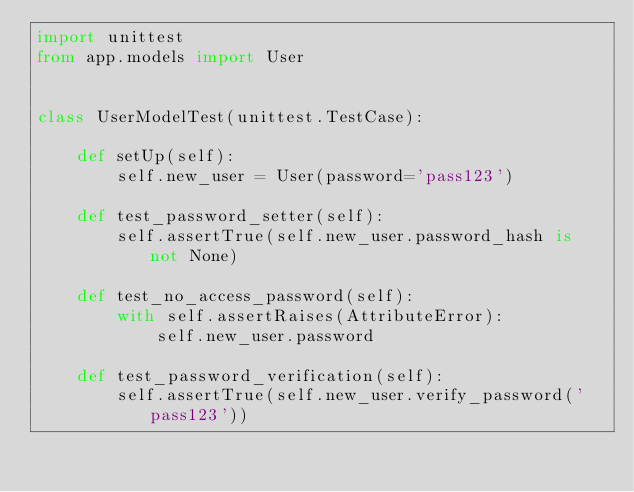<code> <loc_0><loc_0><loc_500><loc_500><_Python_>import unittest
from app.models import User


class UserModelTest(unittest.TestCase):

    def setUp(self):
        self.new_user = User(password='pass123')

    def test_password_setter(self):
        self.assertTrue(self.new_user.password_hash is not None)

    def test_no_access_password(self):
        with self.assertRaises(AttributeError):
            self.new_user.password

    def test_password_verification(self):
        self.assertTrue(self.new_user.verify_password('pass123'))
</code> 